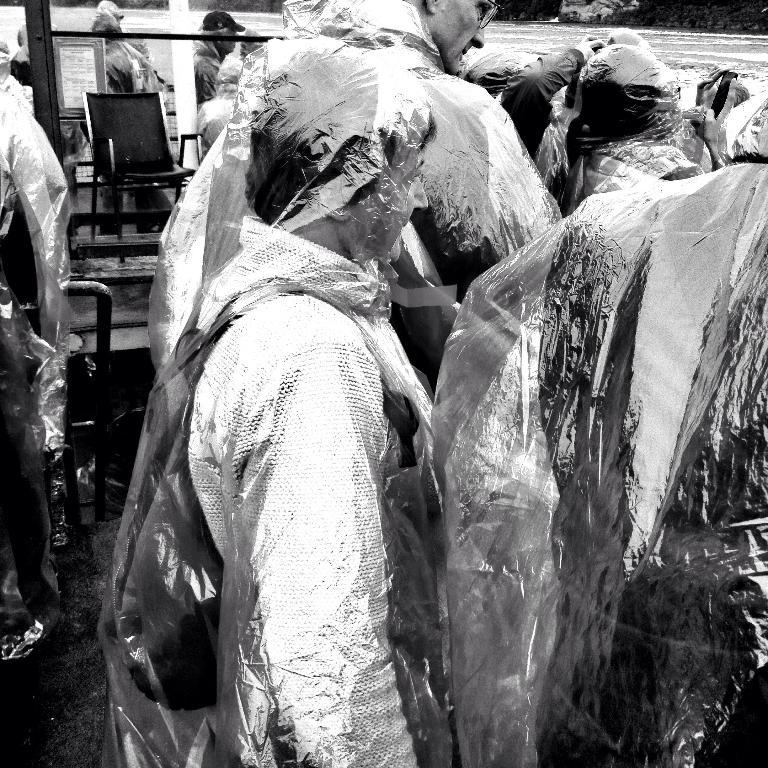What is the main subject of the image? The main subject of the image is a group of people. What are the people in the image doing? The people are standing. What are the people wearing in the image? The people are wearing covers on their bodies. What type of wax can be seen dripping from the eggnog in the image? There is no eggnog or wax present in the image. How many balloons are being held by the people in the image? There is no mention of balloons in the image; the people are wearing covers on their bodies. 